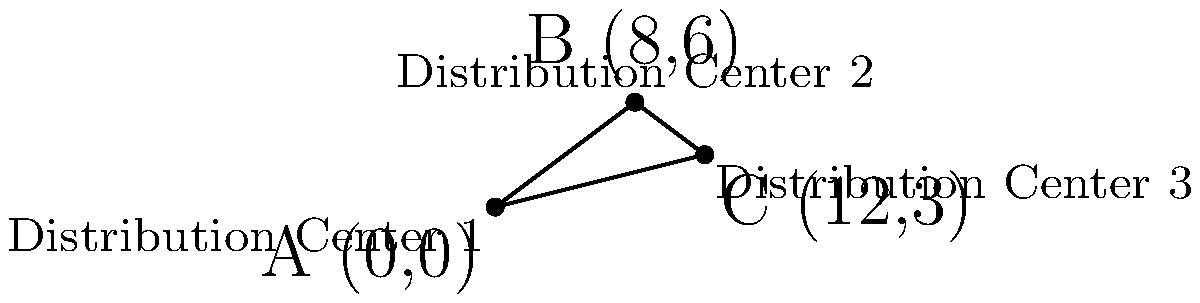As a retail store owner, you're optimizing your distribution network. You have three distribution centers located at coordinates A(0,0), B(8,6), and C(12,3). To minimize transportation costs, you need to find the shortest distance between any two centers. Calculate the shortest distance between two distribution centers using the distance formula. Round your answer to two decimal places. To solve this problem, we'll use the distance formula between two points: $d = \sqrt{(x_2-x_1)^2 + (y_2-y_1)^2}$

Let's calculate the distance between each pair of points:

1. Distance between A and B:
   $d_{AB} = \sqrt{(8-0)^2 + (6-0)^2} = \sqrt{64 + 36} = \sqrt{100} = 10$

2. Distance between B and C:
   $d_{BC} = \sqrt{(12-8)^2 + (3-6)^2} = \sqrt{16 + 9} = \sqrt{25} = 5$

3. Distance between A and C:
   $d_{AC} = \sqrt{(12-0)^2 + (3-0)^2} = \sqrt{144 + 9} = \sqrt{153} \approx 12.37$

The shortest distance is between points B and C, which is 5 units.
Answer: 5 units 